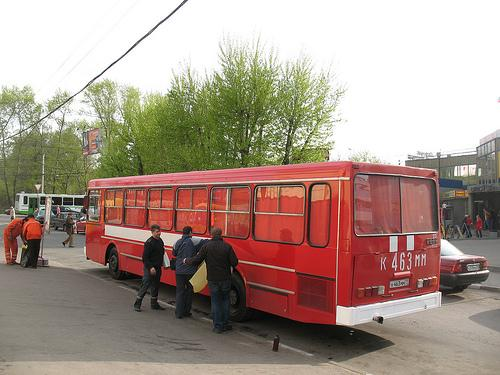Write a brief sentence describing the scene with the bus and men in it. Three men are standing near a large red and white bus with its windows covered in red curtains. What is the primary mode of transportation featured in this image? The primary mode of transportation is a large red and white bus. How many clouds are visible in the image and what colors are they? There are nine white clouds visible against the blue sky. Briefly narrate the image capturing the essence of the scene. The image depicts a bustling street scene with a large red and white bus surrounded by three men, a billboard, and power lines overhead, set against a blue sky filled with white clouds. Count the number of windows on the bus, as well as their largest and smallest sizes in breadth. There are 11 windows on the bus, with the largest width being 83 and the smallest width being 9. List three of the bus window positions, including their X and Y coordinates. Three bus windows, with their X and Y coordinates, are (101,188), (125,188), and (147,186). What color are the curtains on the bus windows? The curtains on the bus windows are red. What type of sign is visible near the bus and what are its colors? A red and white yield sign is visible near the bus. Describe one of the men standing near the bus. One man near the bus is wearing a neon orange jacket. Identify the object with the smallest sized image and describe it. The smallest object has a image of 7x7; it is the head of a man. List all the objects found in the image that relate to transportation. Large red and white bus, part of a red car, black bus tire, burgundy car next to the red bus, and red bus. Compose a haiku about the image. Red bus stands still, waiting Examine the image and comment on the power lines. There are black electrical power lines over the street. What is the main activity happening in the image? Men are standing near a red bus. Describe the scene of the image with a focus on the weather and people. Three men, two in orange and one in black, are standing near a red bus on a sunny day with white clouds in the blue sky. What is the main color of the bus in the image? Red and white What is the color of the bus in the image, and what number is displayed on its back? Choose the correct option. A) Red, 463 B) Green, 27 C) Blue, 165 D) Yellow, 348 A) Red, 463 How many of the bus windows are covered in red curtains? 1 Which objects in the image are associated with the sky? White clouds and blue sky. Is there a yield sign in the image? If so, describe its colors. Yes, it is red and white. Count the number of windows on the bus. 10 What is the man in the orange jacket doing in the image? Walking. 